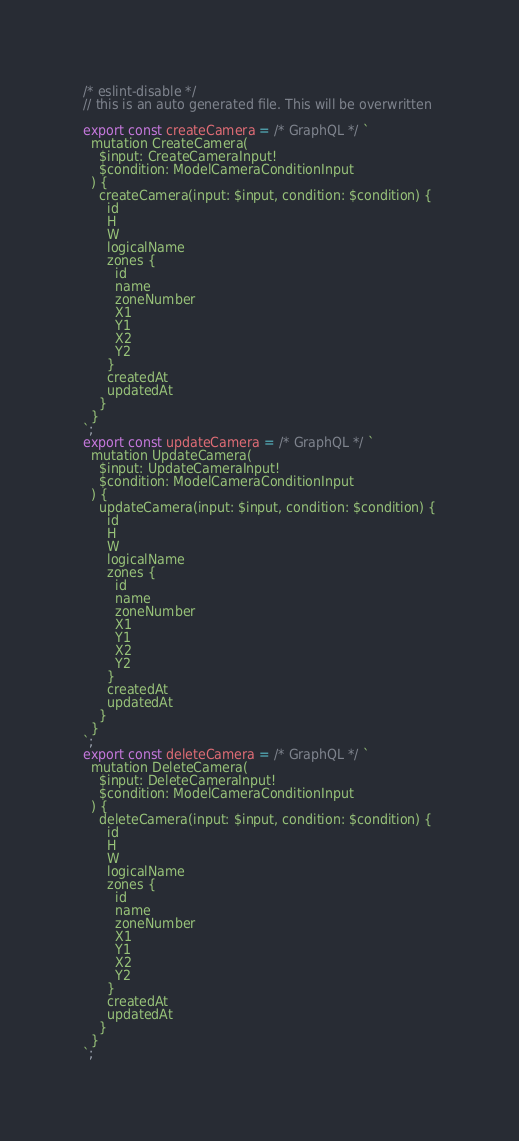Convert code to text. <code><loc_0><loc_0><loc_500><loc_500><_JavaScript_>/* eslint-disable */
// this is an auto generated file. This will be overwritten

export const createCamera = /* GraphQL */ `
  mutation CreateCamera(
    $input: CreateCameraInput!
    $condition: ModelCameraConditionInput
  ) {
    createCamera(input: $input, condition: $condition) {
      id
      H
      W
      logicalName
      zones {
        id
        name
        zoneNumber
        X1
        Y1
        X2
        Y2
      }
      createdAt
      updatedAt
    }
  }
`;
export const updateCamera = /* GraphQL */ `
  mutation UpdateCamera(
    $input: UpdateCameraInput!
    $condition: ModelCameraConditionInput
  ) {
    updateCamera(input: $input, condition: $condition) {
      id
      H
      W
      logicalName
      zones {
        id
        name
        zoneNumber
        X1
        Y1
        X2
        Y2
      }
      createdAt
      updatedAt
    }
  }
`;
export const deleteCamera = /* GraphQL */ `
  mutation DeleteCamera(
    $input: DeleteCameraInput!
    $condition: ModelCameraConditionInput
  ) {
    deleteCamera(input: $input, condition: $condition) {
      id
      H
      W
      logicalName
      zones {
        id
        name
        zoneNumber
        X1
        Y1
        X2
        Y2
      }
      createdAt
      updatedAt
    }
  }
`;
</code> 